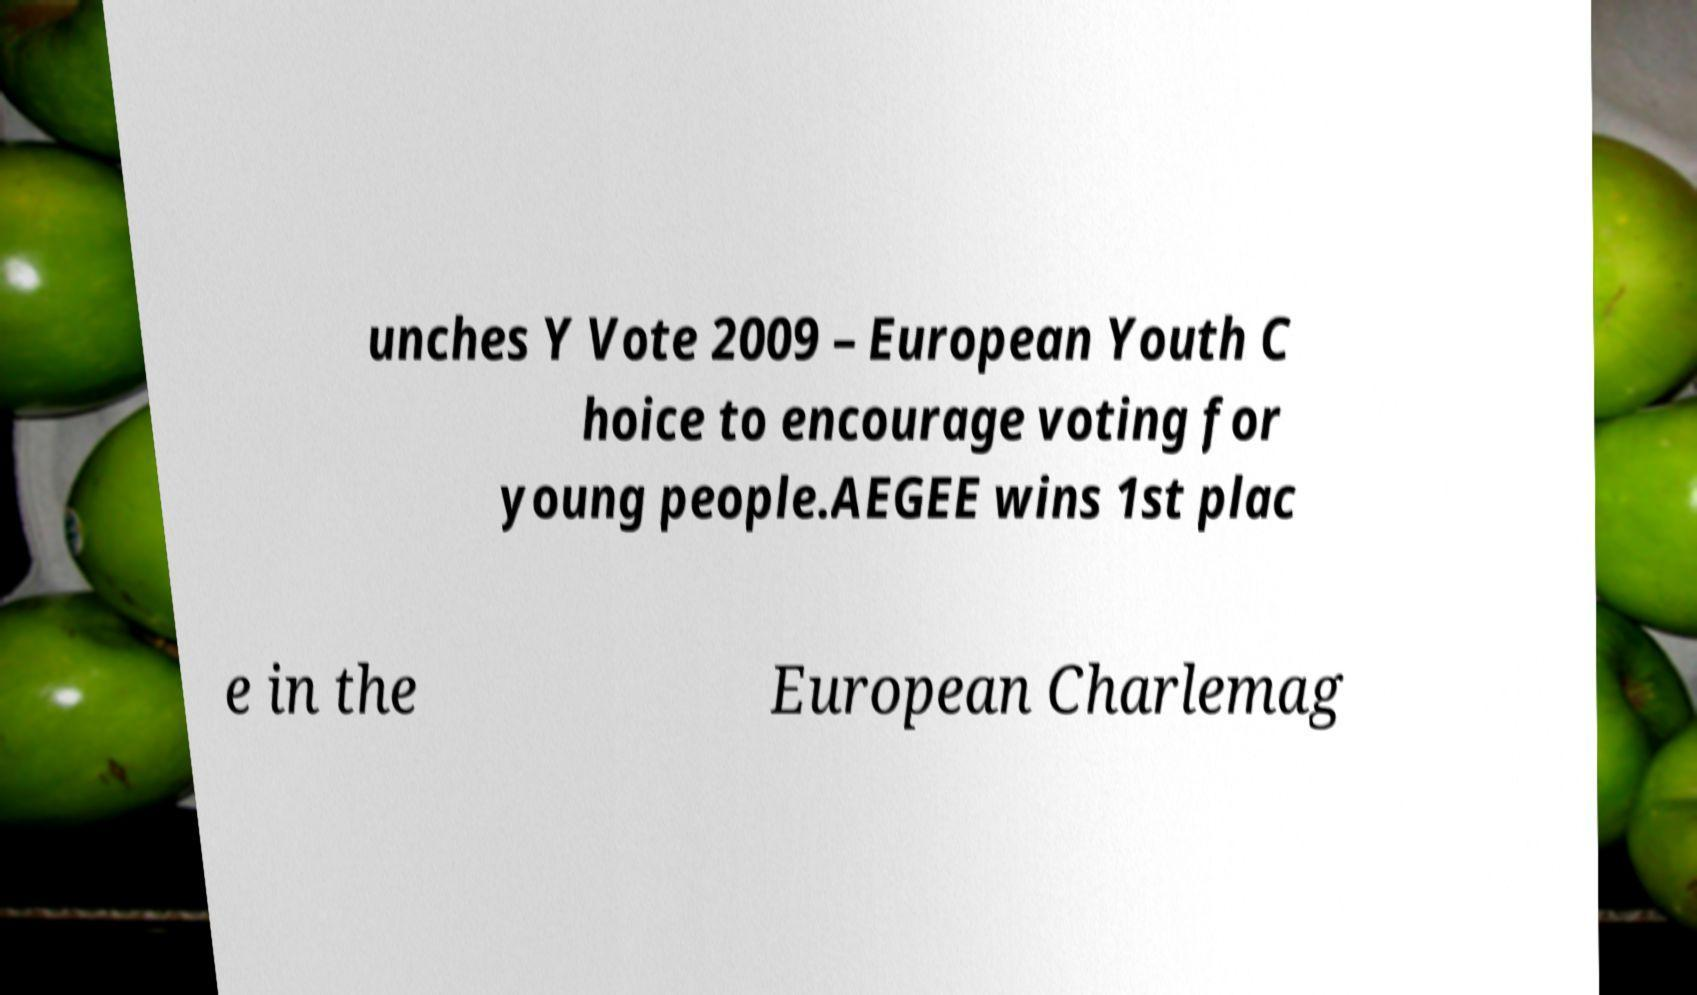Please identify and transcribe the text found in this image. unches Y Vote 2009 – European Youth C hoice to encourage voting for young people.AEGEE wins 1st plac e in the European Charlemag 